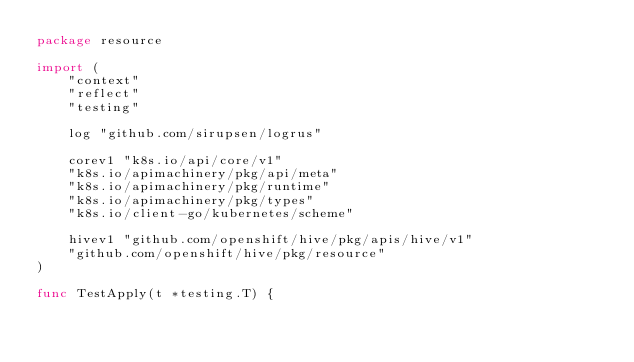<code> <loc_0><loc_0><loc_500><loc_500><_Go_>package resource

import (
	"context"
	"reflect"
	"testing"

	log "github.com/sirupsen/logrus"

	corev1 "k8s.io/api/core/v1"
	"k8s.io/apimachinery/pkg/api/meta"
	"k8s.io/apimachinery/pkg/runtime"
	"k8s.io/apimachinery/pkg/types"
	"k8s.io/client-go/kubernetes/scheme"

	hivev1 "github.com/openshift/hive/pkg/apis/hive/v1"
	"github.com/openshift/hive/pkg/resource"
)

func TestApply(t *testing.T) {</code> 